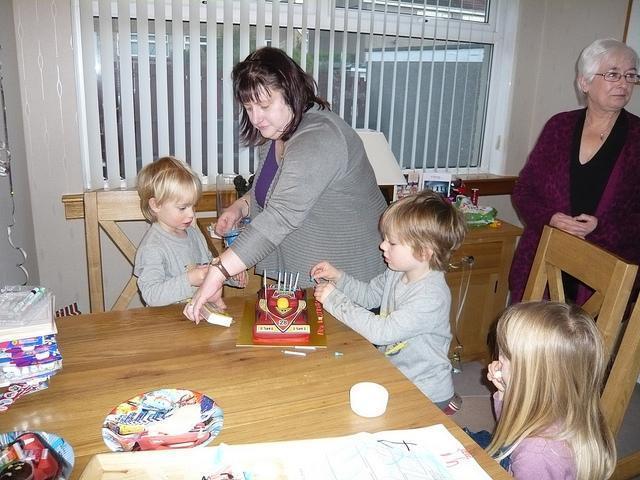How many kids are there?
Give a very brief answer. 3. How many women are wearing glasses?
Give a very brief answer. 1. How many chairs can be seen?
Give a very brief answer. 3. How many people can you see?
Give a very brief answer. 5. How many benches are pictured?
Give a very brief answer. 0. 